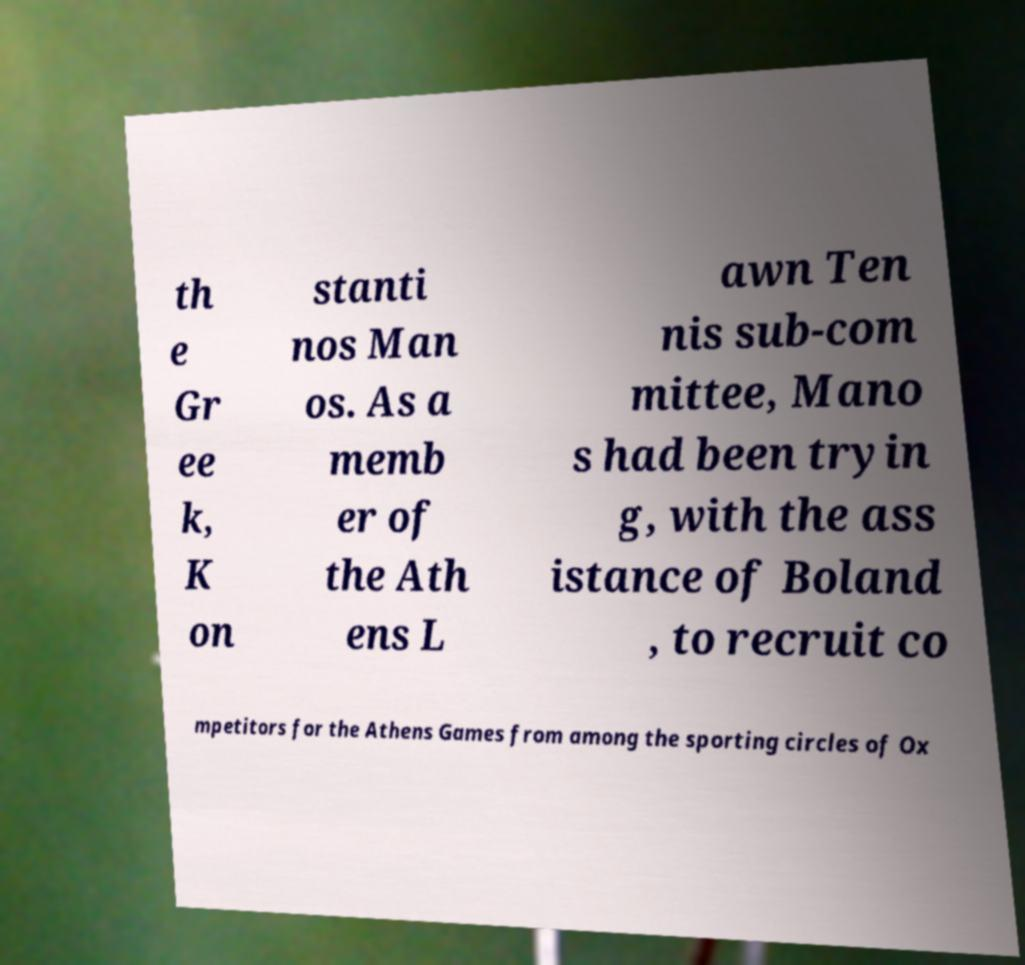Please identify and transcribe the text found in this image. th e Gr ee k, K on stanti nos Man os. As a memb er of the Ath ens L awn Ten nis sub-com mittee, Mano s had been tryin g, with the ass istance of Boland , to recruit co mpetitors for the Athens Games from among the sporting circles of Ox 